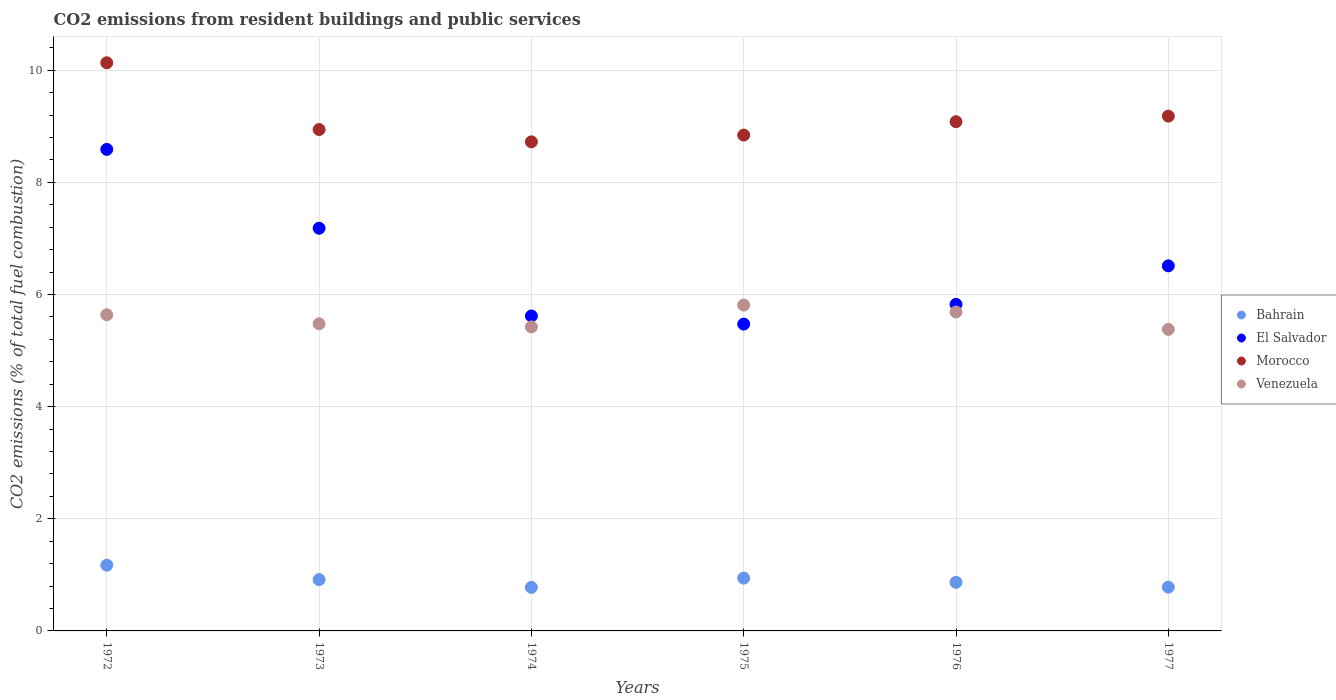Is the number of dotlines equal to the number of legend labels?
Your response must be concise. Yes. What is the total CO2 emitted in Bahrain in 1974?
Keep it short and to the point. 0.78. Across all years, what is the maximum total CO2 emitted in Bahrain?
Give a very brief answer. 1.17. Across all years, what is the minimum total CO2 emitted in Venezuela?
Your answer should be very brief. 5.38. In which year was the total CO2 emitted in El Salvador maximum?
Make the answer very short. 1972. In which year was the total CO2 emitted in Morocco minimum?
Provide a succinct answer. 1974. What is the total total CO2 emitted in Bahrain in the graph?
Offer a terse response. 5.45. What is the difference between the total CO2 emitted in Morocco in 1972 and that in 1976?
Ensure brevity in your answer.  1.05. What is the difference between the total CO2 emitted in Bahrain in 1972 and the total CO2 emitted in Venezuela in 1977?
Provide a succinct answer. -4.21. What is the average total CO2 emitted in El Salvador per year?
Offer a terse response. 6.53. In the year 1974, what is the difference between the total CO2 emitted in Morocco and total CO2 emitted in Bahrain?
Your answer should be very brief. 7.95. What is the ratio of the total CO2 emitted in El Salvador in 1975 to that in 1977?
Provide a succinct answer. 0.84. Is the total CO2 emitted in Bahrain in 1972 less than that in 1974?
Your response must be concise. No. Is the difference between the total CO2 emitted in Morocco in 1972 and 1974 greater than the difference between the total CO2 emitted in Bahrain in 1972 and 1974?
Provide a short and direct response. Yes. What is the difference between the highest and the second highest total CO2 emitted in Bahrain?
Your answer should be compact. 0.23. What is the difference between the highest and the lowest total CO2 emitted in Bahrain?
Provide a succinct answer. 0.4. Is it the case that in every year, the sum of the total CO2 emitted in Morocco and total CO2 emitted in Venezuela  is greater than the sum of total CO2 emitted in Bahrain and total CO2 emitted in El Salvador?
Provide a short and direct response. Yes. How many years are there in the graph?
Provide a short and direct response. 6. Are the values on the major ticks of Y-axis written in scientific E-notation?
Your answer should be very brief. No. Does the graph contain grids?
Give a very brief answer. Yes. How many legend labels are there?
Ensure brevity in your answer.  4. What is the title of the graph?
Offer a terse response. CO2 emissions from resident buildings and public services. Does "Bosnia and Herzegovina" appear as one of the legend labels in the graph?
Give a very brief answer. No. What is the label or title of the Y-axis?
Keep it short and to the point. CO2 emissions (% of total fuel combustion). What is the CO2 emissions (% of total fuel combustion) in Bahrain in 1972?
Offer a very short reply. 1.17. What is the CO2 emissions (% of total fuel combustion) of El Salvador in 1972?
Keep it short and to the point. 8.59. What is the CO2 emissions (% of total fuel combustion) in Morocco in 1972?
Your answer should be very brief. 10.13. What is the CO2 emissions (% of total fuel combustion) in Venezuela in 1972?
Provide a short and direct response. 5.64. What is the CO2 emissions (% of total fuel combustion) in Bahrain in 1973?
Ensure brevity in your answer.  0.92. What is the CO2 emissions (% of total fuel combustion) of El Salvador in 1973?
Your response must be concise. 7.18. What is the CO2 emissions (% of total fuel combustion) in Morocco in 1973?
Offer a very short reply. 8.94. What is the CO2 emissions (% of total fuel combustion) in Venezuela in 1973?
Your answer should be compact. 5.48. What is the CO2 emissions (% of total fuel combustion) of Bahrain in 1974?
Offer a very short reply. 0.78. What is the CO2 emissions (% of total fuel combustion) in El Salvador in 1974?
Give a very brief answer. 5.62. What is the CO2 emissions (% of total fuel combustion) in Morocco in 1974?
Ensure brevity in your answer.  8.72. What is the CO2 emissions (% of total fuel combustion) of Venezuela in 1974?
Your answer should be very brief. 5.42. What is the CO2 emissions (% of total fuel combustion) of Bahrain in 1975?
Your answer should be compact. 0.94. What is the CO2 emissions (% of total fuel combustion) in El Salvador in 1975?
Keep it short and to the point. 5.47. What is the CO2 emissions (% of total fuel combustion) of Morocco in 1975?
Provide a short and direct response. 8.84. What is the CO2 emissions (% of total fuel combustion) in Venezuela in 1975?
Provide a short and direct response. 5.81. What is the CO2 emissions (% of total fuel combustion) in Bahrain in 1976?
Ensure brevity in your answer.  0.87. What is the CO2 emissions (% of total fuel combustion) of El Salvador in 1976?
Give a very brief answer. 5.83. What is the CO2 emissions (% of total fuel combustion) in Morocco in 1976?
Make the answer very short. 9.08. What is the CO2 emissions (% of total fuel combustion) in Venezuela in 1976?
Ensure brevity in your answer.  5.69. What is the CO2 emissions (% of total fuel combustion) in Bahrain in 1977?
Provide a short and direct response. 0.78. What is the CO2 emissions (% of total fuel combustion) of El Salvador in 1977?
Provide a succinct answer. 6.51. What is the CO2 emissions (% of total fuel combustion) in Morocco in 1977?
Ensure brevity in your answer.  9.18. What is the CO2 emissions (% of total fuel combustion) in Venezuela in 1977?
Keep it short and to the point. 5.38. Across all years, what is the maximum CO2 emissions (% of total fuel combustion) in Bahrain?
Give a very brief answer. 1.17. Across all years, what is the maximum CO2 emissions (% of total fuel combustion) in El Salvador?
Your response must be concise. 8.59. Across all years, what is the maximum CO2 emissions (% of total fuel combustion) of Morocco?
Provide a succinct answer. 10.13. Across all years, what is the maximum CO2 emissions (% of total fuel combustion) in Venezuela?
Provide a short and direct response. 5.81. Across all years, what is the minimum CO2 emissions (% of total fuel combustion) of Bahrain?
Your answer should be compact. 0.78. Across all years, what is the minimum CO2 emissions (% of total fuel combustion) in El Salvador?
Ensure brevity in your answer.  5.47. Across all years, what is the minimum CO2 emissions (% of total fuel combustion) of Morocco?
Your response must be concise. 8.72. Across all years, what is the minimum CO2 emissions (% of total fuel combustion) of Venezuela?
Make the answer very short. 5.38. What is the total CO2 emissions (% of total fuel combustion) in Bahrain in the graph?
Ensure brevity in your answer.  5.45. What is the total CO2 emissions (% of total fuel combustion) in El Salvador in the graph?
Your answer should be very brief. 39.2. What is the total CO2 emissions (% of total fuel combustion) of Morocco in the graph?
Give a very brief answer. 54.91. What is the total CO2 emissions (% of total fuel combustion) of Venezuela in the graph?
Offer a very short reply. 33.42. What is the difference between the CO2 emissions (% of total fuel combustion) in Bahrain in 1972 and that in 1973?
Provide a succinct answer. 0.26. What is the difference between the CO2 emissions (% of total fuel combustion) of El Salvador in 1972 and that in 1973?
Make the answer very short. 1.41. What is the difference between the CO2 emissions (% of total fuel combustion) of Morocco in 1972 and that in 1973?
Your answer should be very brief. 1.19. What is the difference between the CO2 emissions (% of total fuel combustion) in Venezuela in 1972 and that in 1973?
Keep it short and to the point. 0.16. What is the difference between the CO2 emissions (% of total fuel combustion) of Bahrain in 1972 and that in 1974?
Keep it short and to the point. 0.4. What is the difference between the CO2 emissions (% of total fuel combustion) of El Salvador in 1972 and that in 1974?
Your response must be concise. 2.97. What is the difference between the CO2 emissions (% of total fuel combustion) of Morocco in 1972 and that in 1974?
Your response must be concise. 1.41. What is the difference between the CO2 emissions (% of total fuel combustion) of Venezuela in 1972 and that in 1974?
Make the answer very short. 0.22. What is the difference between the CO2 emissions (% of total fuel combustion) of Bahrain in 1972 and that in 1975?
Ensure brevity in your answer.  0.23. What is the difference between the CO2 emissions (% of total fuel combustion) of El Salvador in 1972 and that in 1975?
Provide a succinct answer. 3.12. What is the difference between the CO2 emissions (% of total fuel combustion) of Morocco in 1972 and that in 1975?
Your answer should be very brief. 1.29. What is the difference between the CO2 emissions (% of total fuel combustion) in Venezuela in 1972 and that in 1975?
Offer a terse response. -0.17. What is the difference between the CO2 emissions (% of total fuel combustion) in Bahrain in 1972 and that in 1976?
Your answer should be very brief. 0.31. What is the difference between the CO2 emissions (% of total fuel combustion) of El Salvador in 1972 and that in 1976?
Provide a short and direct response. 2.76. What is the difference between the CO2 emissions (% of total fuel combustion) of Morocco in 1972 and that in 1976?
Offer a very short reply. 1.05. What is the difference between the CO2 emissions (% of total fuel combustion) in Venezuela in 1972 and that in 1976?
Provide a short and direct response. -0.05. What is the difference between the CO2 emissions (% of total fuel combustion) in Bahrain in 1972 and that in 1977?
Offer a terse response. 0.39. What is the difference between the CO2 emissions (% of total fuel combustion) of El Salvador in 1972 and that in 1977?
Provide a short and direct response. 2.08. What is the difference between the CO2 emissions (% of total fuel combustion) of Morocco in 1972 and that in 1977?
Ensure brevity in your answer.  0.95. What is the difference between the CO2 emissions (% of total fuel combustion) of Venezuela in 1972 and that in 1977?
Your answer should be compact. 0.26. What is the difference between the CO2 emissions (% of total fuel combustion) in Bahrain in 1973 and that in 1974?
Keep it short and to the point. 0.14. What is the difference between the CO2 emissions (% of total fuel combustion) in El Salvador in 1973 and that in 1974?
Make the answer very short. 1.56. What is the difference between the CO2 emissions (% of total fuel combustion) of Morocco in 1973 and that in 1974?
Make the answer very short. 0.22. What is the difference between the CO2 emissions (% of total fuel combustion) in Venezuela in 1973 and that in 1974?
Provide a succinct answer. 0.06. What is the difference between the CO2 emissions (% of total fuel combustion) of Bahrain in 1973 and that in 1975?
Keep it short and to the point. -0.03. What is the difference between the CO2 emissions (% of total fuel combustion) of El Salvador in 1973 and that in 1975?
Provide a short and direct response. 1.71. What is the difference between the CO2 emissions (% of total fuel combustion) of Morocco in 1973 and that in 1975?
Provide a succinct answer. 0.1. What is the difference between the CO2 emissions (% of total fuel combustion) in Venezuela in 1973 and that in 1975?
Keep it short and to the point. -0.33. What is the difference between the CO2 emissions (% of total fuel combustion) in Bahrain in 1973 and that in 1976?
Give a very brief answer. 0.05. What is the difference between the CO2 emissions (% of total fuel combustion) of El Salvador in 1973 and that in 1976?
Make the answer very short. 1.36. What is the difference between the CO2 emissions (% of total fuel combustion) of Morocco in 1973 and that in 1976?
Make the answer very short. -0.14. What is the difference between the CO2 emissions (% of total fuel combustion) of Venezuela in 1973 and that in 1976?
Offer a very short reply. -0.21. What is the difference between the CO2 emissions (% of total fuel combustion) of Bahrain in 1973 and that in 1977?
Provide a succinct answer. 0.13. What is the difference between the CO2 emissions (% of total fuel combustion) in El Salvador in 1973 and that in 1977?
Offer a very short reply. 0.67. What is the difference between the CO2 emissions (% of total fuel combustion) of Morocco in 1973 and that in 1977?
Give a very brief answer. -0.24. What is the difference between the CO2 emissions (% of total fuel combustion) in Venezuela in 1973 and that in 1977?
Keep it short and to the point. 0.1. What is the difference between the CO2 emissions (% of total fuel combustion) in Bahrain in 1974 and that in 1975?
Offer a very short reply. -0.16. What is the difference between the CO2 emissions (% of total fuel combustion) of El Salvador in 1974 and that in 1975?
Offer a terse response. 0.15. What is the difference between the CO2 emissions (% of total fuel combustion) in Morocco in 1974 and that in 1975?
Your answer should be very brief. -0.12. What is the difference between the CO2 emissions (% of total fuel combustion) of Venezuela in 1974 and that in 1975?
Your response must be concise. -0.39. What is the difference between the CO2 emissions (% of total fuel combustion) in Bahrain in 1974 and that in 1976?
Ensure brevity in your answer.  -0.09. What is the difference between the CO2 emissions (% of total fuel combustion) in El Salvador in 1974 and that in 1976?
Offer a terse response. -0.21. What is the difference between the CO2 emissions (% of total fuel combustion) in Morocco in 1974 and that in 1976?
Give a very brief answer. -0.36. What is the difference between the CO2 emissions (% of total fuel combustion) of Venezuela in 1974 and that in 1976?
Offer a very short reply. -0.27. What is the difference between the CO2 emissions (% of total fuel combustion) in Bahrain in 1974 and that in 1977?
Provide a short and direct response. -0. What is the difference between the CO2 emissions (% of total fuel combustion) of El Salvador in 1974 and that in 1977?
Your answer should be very brief. -0.89. What is the difference between the CO2 emissions (% of total fuel combustion) in Morocco in 1974 and that in 1977?
Your answer should be compact. -0.46. What is the difference between the CO2 emissions (% of total fuel combustion) of Venezuela in 1974 and that in 1977?
Provide a succinct answer. 0.04. What is the difference between the CO2 emissions (% of total fuel combustion) of Bahrain in 1975 and that in 1976?
Your answer should be very brief. 0.08. What is the difference between the CO2 emissions (% of total fuel combustion) of El Salvador in 1975 and that in 1976?
Your answer should be compact. -0.35. What is the difference between the CO2 emissions (% of total fuel combustion) in Morocco in 1975 and that in 1976?
Your answer should be compact. -0.24. What is the difference between the CO2 emissions (% of total fuel combustion) in Venezuela in 1975 and that in 1976?
Ensure brevity in your answer.  0.12. What is the difference between the CO2 emissions (% of total fuel combustion) of Bahrain in 1975 and that in 1977?
Offer a very short reply. 0.16. What is the difference between the CO2 emissions (% of total fuel combustion) in El Salvador in 1975 and that in 1977?
Ensure brevity in your answer.  -1.04. What is the difference between the CO2 emissions (% of total fuel combustion) in Morocco in 1975 and that in 1977?
Give a very brief answer. -0.34. What is the difference between the CO2 emissions (% of total fuel combustion) of Venezuela in 1975 and that in 1977?
Provide a succinct answer. 0.43. What is the difference between the CO2 emissions (% of total fuel combustion) in Bahrain in 1976 and that in 1977?
Keep it short and to the point. 0.09. What is the difference between the CO2 emissions (% of total fuel combustion) in El Salvador in 1976 and that in 1977?
Offer a very short reply. -0.69. What is the difference between the CO2 emissions (% of total fuel combustion) in Morocco in 1976 and that in 1977?
Your answer should be very brief. -0.1. What is the difference between the CO2 emissions (% of total fuel combustion) in Venezuela in 1976 and that in 1977?
Your answer should be very brief. 0.31. What is the difference between the CO2 emissions (% of total fuel combustion) in Bahrain in 1972 and the CO2 emissions (% of total fuel combustion) in El Salvador in 1973?
Offer a terse response. -6.01. What is the difference between the CO2 emissions (% of total fuel combustion) of Bahrain in 1972 and the CO2 emissions (% of total fuel combustion) of Morocco in 1973?
Your answer should be very brief. -7.77. What is the difference between the CO2 emissions (% of total fuel combustion) of Bahrain in 1972 and the CO2 emissions (% of total fuel combustion) of Venezuela in 1973?
Your response must be concise. -4.31. What is the difference between the CO2 emissions (% of total fuel combustion) of El Salvador in 1972 and the CO2 emissions (% of total fuel combustion) of Morocco in 1973?
Offer a terse response. -0.35. What is the difference between the CO2 emissions (% of total fuel combustion) of El Salvador in 1972 and the CO2 emissions (% of total fuel combustion) of Venezuela in 1973?
Your response must be concise. 3.11. What is the difference between the CO2 emissions (% of total fuel combustion) of Morocco in 1972 and the CO2 emissions (% of total fuel combustion) of Venezuela in 1973?
Provide a succinct answer. 4.66. What is the difference between the CO2 emissions (% of total fuel combustion) in Bahrain in 1972 and the CO2 emissions (% of total fuel combustion) in El Salvador in 1974?
Your response must be concise. -4.45. What is the difference between the CO2 emissions (% of total fuel combustion) of Bahrain in 1972 and the CO2 emissions (% of total fuel combustion) of Morocco in 1974?
Offer a terse response. -7.55. What is the difference between the CO2 emissions (% of total fuel combustion) of Bahrain in 1972 and the CO2 emissions (% of total fuel combustion) of Venezuela in 1974?
Provide a short and direct response. -4.25. What is the difference between the CO2 emissions (% of total fuel combustion) of El Salvador in 1972 and the CO2 emissions (% of total fuel combustion) of Morocco in 1974?
Make the answer very short. -0.13. What is the difference between the CO2 emissions (% of total fuel combustion) of El Salvador in 1972 and the CO2 emissions (% of total fuel combustion) of Venezuela in 1974?
Your answer should be compact. 3.17. What is the difference between the CO2 emissions (% of total fuel combustion) of Morocco in 1972 and the CO2 emissions (% of total fuel combustion) of Venezuela in 1974?
Make the answer very short. 4.71. What is the difference between the CO2 emissions (% of total fuel combustion) in Bahrain in 1972 and the CO2 emissions (% of total fuel combustion) in El Salvador in 1975?
Offer a very short reply. -4.3. What is the difference between the CO2 emissions (% of total fuel combustion) in Bahrain in 1972 and the CO2 emissions (% of total fuel combustion) in Morocco in 1975?
Provide a short and direct response. -7.67. What is the difference between the CO2 emissions (% of total fuel combustion) in Bahrain in 1972 and the CO2 emissions (% of total fuel combustion) in Venezuela in 1975?
Make the answer very short. -4.64. What is the difference between the CO2 emissions (% of total fuel combustion) in El Salvador in 1972 and the CO2 emissions (% of total fuel combustion) in Morocco in 1975?
Provide a short and direct response. -0.26. What is the difference between the CO2 emissions (% of total fuel combustion) in El Salvador in 1972 and the CO2 emissions (% of total fuel combustion) in Venezuela in 1975?
Offer a terse response. 2.78. What is the difference between the CO2 emissions (% of total fuel combustion) in Morocco in 1972 and the CO2 emissions (% of total fuel combustion) in Venezuela in 1975?
Make the answer very short. 4.32. What is the difference between the CO2 emissions (% of total fuel combustion) of Bahrain in 1972 and the CO2 emissions (% of total fuel combustion) of El Salvador in 1976?
Your answer should be compact. -4.65. What is the difference between the CO2 emissions (% of total fuel combustion) of Bahrain in 1972 and the CO2 emissions (% of total fuel combustion) of Morocco in 1976?
Offer a very short reply. -7.91. What is the difference between the CO2 emissions (% of total fuel combustion) in Bahrain in 1972 and the CO2 emissions (% of total fuel combustion) in Venezuela in 1976?
Provide a short and direct response. -4.52. What is the difference between the CO2 emissions (% of total fuel combustion) of El Salvador in 1972 and the CO2 emissions (% of total fuel combustion) of Morocco in 1976?
Your response must be concise. -0.49. What is the difference between the CO2 emissions (% of total fuel combustion) in El Salvador in 1972 and the CO2 emissions (% of total fuel combustion) in Venezuela in 1976?
Your response must be concise. 2.9. What is the difference between the CO2 emissions (% of total fuel combustion) in Morocco in 1972 and the CO2 emissions (% of total fuel combustion) in Venezuela in 1976?
Ensure brevity in your answer.  4.44. What is the difference between the CO2 emissions (% of total fuel combustion) in Bahrain in 1972 and the CO2 emissions (% of total fuel combustion) in El Salvador in 1977?
Your answer should be compact. -5.34. What is the difference between the CO2 emissions (% of total fuel combustion) of Bahrain in 1972 and the CO2 emissions (% of total fuel combustion) of Morocco in 1977?
Your response must be concise. -8.01. What is the difference between the CO2 emissions (% of total fuel combustion) of Bahrain in 1972 and the CO2 emissions (% of total fuel combustion) of Venezuela in 1977?
Keep it short and to the point. -4.21. What is the difference between the CO2 emissions (% of total fuel combustion) of El Salvador in 1972 and the CO2 emissions (% of total fuel combustion) of Morocco in 1977?
Your answer should be very brief. -0.59. What is the difference between the CO2 emissions (% of total fuel combustion) of El Salvador in 1972 and the CO2 emissions (% of total fuel combustion) of Venezuela in 1977?
Offer a very short reply. 3.21. What is the difference between the CO2 emissions (% of total fuel combustion) in Morocco in 1972 and the CO2 emissions (% of total fuel combustion) in Venezuela in 1977?
Make the answer very short. 4.75. What is the difference between the CO2 emissions (% of total fuel combustion) of Bahrain in 1973 and the CO2 emissions (% of total fuel combustion) of El Salvador in 1974?
Ensure brevity in your answer.  -4.7. What is the difference between the CO2 emissions (% of total fuel combustion) in Bahrain in 1973 and the CO2 emissions (% of total fuel combustion) in Morocco in 1974?
Give a very brief answer. -7.81. What is the difference between the CO2 emissions (% of total fuel combustion) in Bahrain in 1973 and the CO2 emissions (% of total fuel combustion) in Venezuela in 1974?
Your answer should be compact. -4.51. What is the difference between the CO2 emissions (% of total fuel combustion) of El Salvador in 1973 and the CO2 emissions (% of total fuel combustion) of Morocco in 1974?
Give a very brief answer. -1.54. What is the difference between the CO2 emissions (% of total fuel combustion) in El Salvador in 1973 and the CO2 emissions (% of total fuel combustion) in Venezuela in 1974?
Offer a very short reply. 1.76. What is the difference between the CO2 emissions (% of total fuel combustion) in Morocco in 1973 and the CO2 emissions (% of total fuel combustion) in Venezuela in 1974?
Provide a succinct answer. 3.52. What is the difference between the CO2 emissions (% of total fuel combustion) in Bahrain in 1973 and the CO2 emissions (% of total fuel combustion) in El Salvador in 1975?
Give a very brief answer. -4.56. What is the difference between the CO2 emissions (% of total fuel combustion) of Bahrain in 1973 and the CO2 emissions (% of total fuel combustion) of Morocco in 1975?
Keep it short and to the point. -7.93. What is the difference between the CO2 emissions (% of total fuel combustion) in Bahrain in 1973 and the CO2 emissions (% of total fuel combustion) in Venezuela in 1975?
Offer a terse response. -4.9. What is the difference between the CO2 emissions (% of total fuel combustion) in El Salvador in 1973 and the CO2 emissions (% of total fuel combustion) in Morocco in 1975?
Your response must be concise. -1.66. What is the difference between the CO2 emissions (% of total fuel combustion) in El Salvador in 1973 and the CO2 emissions (% of total fuel combustion) in Venezuela in 1975?
Your answer should be very brief. 1.37. What is the difference between the CO2 emissions (% of total fuel combustion) in Morocco in 1973 and the CO2 emissions (% of total fuel combustion) in Venezuela in 1975?
Give a very brief answer. 3.13. What is the difference between the CO2 emissions (% of total fuel combustion) in Bahrain in 1973 and the CO2 emissions (% of total fuel combustion) in El Salvador in 1976?
Provide a short and direct response. -4.91. What is the difference between the CO2 emissions (% of total fuel combustion) of Bahrain in 1973 and the CO2 emissions (% of total fuel combustion) of Morocco in 1976?
Ensure brevity in your answer.  -8.17. What is the difference between the CO2 emissions (% of total fuel combustion) in Bahrain in 1973 and the CO2 emissions (% of total fuel combustion) in Venezuela in 1976?
Provide a short and direct response. -4.77. What is the difference between the CO2 emissions (% of total fuel combustion) in El Salvador in 1973 and the CO2 emissions (% of total fuel combustion) in Morocco in 1976?
Provide a short and direct response. -1.9. What is the difference between the CO2 emissions (% of total fuel combustion) in El Salvador in 1973 and the CO2 emissions (% of total fuel combustion) in Venezuela in 1976?
Make the answer very short. 1.49. What is the difference between the CO2 emissions (% of total fuel combustion) of Morocco in 1973 and the CO2 emissions (% of total fuel combustion) of Venezuela in 1976?
Provide a short and direct response. 3.25. What is the difference between the CO2 emissions (% of total fuel combustion) of Bahrain in 1973 and the CO2 emissions (% of total fuel combustion) of El Salvador in 1977?
Your answer should be very brief. -5.6. What is the difference between the CO2 emissions (% of total fuel combustion) of Bahrain in 1973 and the CO2 emissions (% of total fuel combustion) of Morocco in 1977?
Your response must be concise. -8.27. What is the difference between the CO2 emissions (% of total fuel combustion) in Bahrain in 1973 and the CO2 emissions (% of total fuel combustion) in Venezuela in 1977?
Your answer should be compact. -4.46. What is the difference between the CO2 emissions (% of total fuel combustion) in El Salvador in 1973 and the CO2 emissions (% of total fuel combustion) in Morocco in 1977?
Offer a terse response. -2. What is the difference between the CO2 emissions (% of total fuel combustion) of El Salvador in 1973 and the CO2 emissions (% of total fuel combustion) of Venezuela in 1977?
Offer a very short reply. 1.8. What is the difference between the CO2 emissions (% of total fuel combustion) of Morocco in 1973 and the CO2 emissions (% of total fuel combustion) of Venezuela in 1977?
Your answer should be very brief. 3.56. What is the difference between the CO2 emissions (% of total fuel combustion) of Bahrain in 1974 and the CO2 emissions (% of total fuel combustion) of El Salvador in 1975?
Your answer should be very brief. -4.7. What is the difference between the CO2 emissions (% of total fuel combustion) in Bahrain in 1974 and the CO2 emissions (% of total fuel combustion) in Morocco in 1975?
Provide a short and direct response. -8.07. What is the difference between the CO2 emissions (% of total fuel combustion) in Bahrain in 1974 and the CO2 emissions (% of total fuel combustion) in Venezuela in 1975?
Keep it short and to the point. -5.04. What is the difference between the CO2 emissions (% of total fuel combustion) in El Salvador in 1974 and the CO2 emissions (% of total fuel combustion) in Morocco in 1975?
Your answer should be compact. -3.23. What is the difference between the CO2 emissions (% of total fuel combustion) in El Salvador in 1974 and the CO2 emissions (% of total fuel combustion) in Venezuela in 1975?
Keep it short and to the point. -0.19. What is the difference between the CO2 emissions (% of total fuel combustion) in Morocco in 1974 and the CO2 emissions (% of total fuel combustion) in Venezuela in 1975?
Give a very brief answer. 2.91. What is the difference between the CO2 emissions (% of total fuel combustion) of Bahrain in 1974 and the CO2 emissions (% of total fuel combustion) of El Salvador in 1976?
Your answer should be very brief. -5.05. What is the difference between the CO2 emissions (% of total fuel combustion) in Bahrain in 1974 and the CO2 emissions (% of total fuel combustion) in Morocco in 1976?
Ensure brevity in your answer.  -8.31. What is the difference between the CO2 emissions (% of total fuel combustion) in Bahrain in 1974 and the CO2 emissions (% of total fuel combustion) in Venezuela in 1976?
Your response must be concise. -4.91. What is the difference between the CO2 emissions (% of total fuel combustion) of El Salvador in 1974 and the CO2 emissions (% of total fuel combustion) of Morocco in 1976?
Make the answer very short. -3.46. What is the difference between the CO2 emissions (% of total fuel combustion) of El Salvador in 1974 and the CO2 emissions (% of total fuel combustion) of Venezuela in 1976?
Your answer should be very brief. -0.07. What is the difference between the CO2 emissions (% of total fuel combustion) of Morocco in 1974 and the CO2 emissions (% of total fuel combustion) of Venezuela in 1976?
Your answer should be very brief. 3.03. What is the difference between the CO2 emissions (% of total fuel combustion) of Bahrain in 1974 and the CO2 emissions (% of total fuel combustion) of El Salvador in 1977?
Provide a succinct answer. -5.73. What is the difference between the CO2 emissions (% of total fuel combustion) in Bahrain in 1974 and the CO2 emissions (% of total fuel combustion) in Morocco in 1977?
Keep it short and to the point. -8.41. What is the difference between the CO2 emissions (% of total fuel combustion) in Bahrain in 1974 and the CO2 emissions (% of total fuel combustion) in Venezuela in 1977?
Your answer should be compact. -4.6. What is the difference between the CO2 emissions (% of total fuel combustion) of El Salvador in 1974 and the CO2 emissions (% of total fuel combustion) of Morocco in 1977?
Provide a succinct answer. -3.56. What is the difference between the CO2 emissions (% of total fuel combustion) of El Salvador in 1974 and the CO2 emissions (% of total fuel combustion) of Venezuela in 1977?
Your answer should be very brief. 0.24. What is the difference between the CO2 emissions (% of total fuel combustion) in Morocco in 1974 and the CO2 emissions (% of total fuel combustion) in Venezuela in 1977?
Give a very brief answer. 3.35. What is the difference between the CO2 emissions (% of total fuel combustion) of Bahrain in 1975 and the CO2 emissions (% of total fuel combustion) of El Salvador in 1976?
Your response must be concise. -4.88. What is the difference between the CO2 emissions (% of total fuel combustion) of Bahrain in 1975 and the CO2 emissions (% of total fuel combustion) of Morocco in 1976?
Keep it short and to the point. -8.14. What is the difference between the CO2 emissions (% of total fuel combustion) of Bahrain in 1975 and the CO2 emissions (% of total fuel combustion) of Venezuela in 1976?
Provide a short and direct response. -4.75. What is the difference between the CO2 emissions (% of total fuel combustion) of El Salvador in 1975 and the CO2 emissions (% of total fuel combustion) of Morocco in 1976?
Keep it short and to the point. -3.61. What is the difference between the CO2 emissions (% of total fuel combustion) of El Salvador in 1975 and the CO2 emissions (% of total fuel combustion) of Venezuela in 1976?
Your answer should be compact. -0.22. What is the difference between the CO2 emissions (% of total fuel combustion) in Morocco in 1975 and the CO2 emissions (% of total fuel combustion) in Venezuela in 1976?
Your answer should be compact. 3.16. What is the difference between the CO2 emissions (% of total fuel combustion) in Bahrain in 1975 and the CO2 emissions (% of total fuel combustion) in El Salvador in 1977?
Keep it short and to the point. -5.57. What is the difference between the CO2 emissions (% of total fuel combustion) in Bahrain in 1975 and the CO2 emissions (% of total fuel combustion) in Morocco in 1977?
Your answer should be compact. -8.24. What is the difference between the CO2 emissions (% of total fuel combustion) in Bahrain in 1975 and the CO2 emissions (% of total fuel combustion) in Venezuela in 1977?
Your response must be concise. -4.44. What is the difference between the CO2 emissions (% of total fuel combustion) of El Salvador in 1975 and the CO2 emissions (% of total fuel combustion) of Morocco in 1977?
Offer a very short reply. -3.71. What is the difference between the CO2 emissions (% of total fuel combustion) of El Salvador in 1975 and the CO2 emissions (% of total fuel combustion) of Venezuela in 1977?
Give a very brief answer. 0.09. What is the difference between the CO2 emissions (% of total fuel combustion) of Morocco in 1975 and the CO2 emissions (% of total fuel combustion) of Venezuela in 1977?
Give a very brief answer. 3.47. What is the difference between the CO2 emissions (% of total fuel combustion) of Bahrain in 1976 and the CO2 emissions (% of total fuel combustion) of El Salvador in 1977?
Keep it short and to the point. -5.65. What is the difference between the CO2 emissions (% of total fuel combustion) in Bahrain in 1976 and the CO2 emissions (% of total fuel combustion) in Morocco in 1977?
Keep it short and to the point. -8.32. What is the difference between the CO2 emissions (% of total fuel combustion) in Bahrain in 1976 and the CO2 emissions (% of total fuel combustion) in Venezuela in 1977?
Make the answer very short. -4.51. What is the difference between the CO2 emissions (% of total fuel combustion) in El Salvador in 1976 and the CO2 emissions (% of total fuel combustion) in Morocco in 1977?
Keep it short and to the point. -3.36. What is the difference between the CO2 emissions (% of total fuel combustion) in El Salvador in 1976 and the CO2 emissions (% of total fuel combustion) in Venezuela in 1977?
Keep it short and to the point. 0.45. What is the difference between the CO2 emissions (% of total fuel combustion) in Morocco in 1976 and the CO2 emissions (% of total fuel combustion) in Venezuela in 1977?
Provide a succinct answer. 3.7. What is the average CO2 emissions (% of total fuel combustion) in El Salvador per year?
Your answer should be compact. 6.53. What is the average CO2 emissions (% of total fuel combustion) of Morocco per year?
Make the answer very short. 9.15. What is the average CO2 emissions (% of total fuel combustion) in Venezuela per year?
Ensure brevity in your answer.  5.57. In the year 1972, what is the difference between the CO2 emissions (% of total fuel combustion) of Bahrain and CO2 emissions (% of total fuel combustion) of El Salvador?
Offer a very short reply. -7.42. In the year 1972, what is the difference between the CO2 emissions (% of total fuel combustion) of Bahrain and CO2 emissions (% of total fuel combustion) of Morocco?
Keep it short and to the point. -8.96. In the year 1972, what is the difference between the CO2 emissions (% of total fuel combustion) of Bahrain and CO2 emissions (% of total fuel combustion) of Venezuela?
Your answer should be compact. -4.47. In the year 1972, what is the difference between the CO2 emissions (% of total fuel combustion) in El Salvador and CO2 emissions (% of total fuel combustion) in Morocco?
Your response must be concise. -1.54. In the year 1972, what is the difference between the CO2 emissions (% of total fuel combustion) in El Salvador and CO2 emissions (% of total fuel combustion) in Venezuela?
Ensure brevity in your answer.  2.95. In the year 1972, what is the difference between the CO2 emissions (% of total fuel combustion) of Morocco and CO2 emissions (% of total fuel combustion) of Venezuela?
Ensure brevity in your answer.  4.49. In the year 1973, what is the difference between the CO2 emissions (% of total fuel combustion) of Bahrain and CO2 emissions (% of total fuel combustion) of El Salvador?
Your answer should be compact. -6.27. In the year 1973, what is the difference between the CO2 emissions (% of total fuel combustion) of Bahrain and CO2 emissions (% of total fuel combustion) of Morocco?
Give a very brief answer. -8.03. In the year 1973, what is the difference between the CO2 emissions (% of total fuel combustion) in Bahrain and CO2 emissions (% of total fuel combustion) in Venezuela?
Give a very brief answer. -4.56. In the year 1973, what is the difference between the CO2 emissions (% of total fuel combustion) of El Salvador and CO2 emissions (% of total fuel combustion) of Morocco?
Your response must be concise. -1.76. In the year 1973, what is the difference between the CO2 emissions (% of total fuel combustion) of El Salvador and CO2 emissions (% of total fuel combustion) of Venezuela?
Your answer should be very brief. 1.7. In the year 1973, what is the difference between the CO2 emissions (% of total fuel combustion) in Morocco and CO2 emissions (% of total fuel combustion) in Venezuela?
Keep it short and to the point. 3.46. In the year 1974, what is the difference between the CO2 emissions (% of total fuel combustion) in Bahrain and CO2 emissions (% of total fuel combustion) in El Salvador?
Provide a succinct answer. -4.84. In the year 1974, what is the difference between the CO2 emissions (% of total fuel combustion) in Bahrain and CO2 emissions (% of total fuel combustion) in Morocco?
Ensure brevity in your answer.  -7.95. In the year 1974, what is the difference between the CO2 emissions (% of total fuel combustion) of Bahrain and CO2 emissions (% of total fuel combustion) of Venezuela?
Your response must be concise. -4.65. In the year 1974, what is the difference between the CO2 emissions (% of total fuel combustion) in El Salvador and CO2 emissions (% of total fuel combustion) in Morocco?
Give a very brief answer. -3.11. In the year 1974, what is the difference between the CO2 emissions (% of total fuel combustion) of El Salvador and CO2 emissions (% of total fuel combustion) of Venezuela?
Give a very brief answer. 0.2. In the year 1974, what is the difference between the CO2 emissions (% of total fuel combustion) of Morocco and CO2 emissions (% of total fuel combustion) of Venezuela?
Offer a terse response. 3.3. In the year 1975, what is the difference between the CO2 emissions (% of total fuel combustion) in Bahrain and CO2 emissions (% of total fuel combustion) in El Salvador?
Keep it short and to the point. -4.53. In the year 1975, what is the difference between the CO2 emissions (% of total fuel combustion) in Bahrain and CO2 emissions (% of total fuel combustion) in Morocco?
Your response must be concise. -7.9. In the year 1975, what is the difference between the CO2 emissions (% of total fuel combustion) of Bahrain and CO2 emissions (% of total fuel combustion) of Venezuela?
Offer a very short reply. -4.87. In the year 1975, what is the difference between the CO2 emissions (% of total fuel combustion) in El Salvador and CO2 emissions (% of total fuel combustion) in Morocco?
Provide a succinct answer. -3.37. In the year 1975, what is the difference between the CO2 emissions (% of total fuel combustion) in El Salvador and CO2 emissions (% of total fuel combustion) in Venezuela?
Offer a very short reply. -0.34. In the year 1975, what is the difference between the CO2 emissions (% of total fuel combustion) in Morocco and CO2 emissions (% of total fuel combustion) in Venezuela?
Your answer should be very brief. 3.03. In the year 1976, what is the difference between the CO2 emissions (% of total fuel combustion) of Bahrain and CO2 emissions (% of total fuel combustion) of El Salvador?
Provide a succinct answer. -4.96. In the year 1976, what is the difference between the CO2 emissions (% of total fuel combustion) in Bahrain and CO2 emissions (% of total fuel combustion) in Morocco?
Your answer should be compact. -8.22. In the year 1976, what is the difference between the CO2 emissions (% of total fuel combustion) in Bahrain and CO2 emissions (% of total fuel combustion) in Venezuela?
Provide a short and direct response. -4.82. In the year 1976, what is the difference between the CO2 emissions (% of total fuel combustion) of El Salvador and CO2 emissions (% of total fuel combustion) of Morocco?
Keep it short and to the point. -3.26. In the year 1976, what is the difference between the CO2 emissions (% of total fuel combustion) of El Salvador and CO2 emissions (% of total fuel combustion) of Venezuela?
Give a very brief answer. 0.14. In the year 1976, what is the difference between the CO2 emissions (% of total fuel combustion) of Morocco and CO2 emissions (% of total fuel combustion) of Venezuela?
Provide a succinct answer. 3.39. In the year 1977, what is the difference between the CO2 emissions (% of total fuel combustion) in Bahrain and CO2 emissions (% of total fuel combustion) in El Salvador?
Provide a succinct answer. -5.73. In the year 1977, what is the difference between the CO2 emissions (% of total fuel combustion) in Bahrain and CO2 emissions (% of total fuel combustion) in Morocco?
Provide a succinct answer. -8.4. In the year 1977, what is the difference between the CO2 emissions (% of total fuel combustion) in Bahrain and CO2 emissions (% of total fuel combustion) in Venezuela?
Provide a short and direct response. -4.6. In the year 1977, what is the difference between the CO2 emissions (% of total fuel combustion) in El Salvador and CO2 emissions (% of total fuel combustion) in Morocco?
Give a very brief answer. -2.67. In the year 1977, what is the difference between the CO2 emissions (% of total fuel combustion) in El Salvador and CO2 emissions (% of total fuel combustion) in Venezuela?
Your answer should be very brief. 1.13. In the year 1977, what is the difference between the CO2 emissions (% of total fuel combustion) in Morocco and CO2 emissions (% of total fuel combustion) in Venezuela?
Provide a short and direct response. 3.8. What is the ratio of the CO2 emissions (% of total fuel combustion) in Bahrain in 1972 to that in 1973?
Keep it short and to the point. 1.28. What is the ratio of the CO2 emissions (% of total fuel combustion) in El Salvador in 1972 to that in 1973?
Offer a terse response. 1.2. What is the ratio of the CO2 emissions (% of total fuel combustion) in Morocco in 1972 to that in 1973?
Offer a very short reply. 1.13. What is the ratio of the CO2 emissions (% of total fuel combustion) of Venezuela in 1972 to that in 1973?
Offer a very short reply. 1.03. What is the ratio of the CO2 emissions (% of total fuel combustion) in Bahrain in 1972 to that in 1974?
Offer a terse response. 1.51. What is the ratio of the CO2 emissions (% of total fuel combustion) of El Salvador in 1972 to that in 1974?
Keep it short and to the point. 1.53. What is the ratio of the CO2 emissions (% of total fuel combustion) in Morocco in 1972 to that in 1974?
Offer a very short reply. 1.16. What is the ratio of the CO2 emissions (% of total fuel combustion) of Venezuela in 1972 to that in 1974?
Provide a succinct answer. 1.04. What is the ratio of the CO2 emissions (% of total fuel combustion) in Bahrain in 1972 to that in 1975?
Ensure brevity in your answer.  1.25. What is the ratio of the CO2 emissions (% of total fuel combustion) in El Salvador in 1972 to that in 1975?
Give a very brief answer. 1.57. What is the ratio of the CO2 emissions (% of total fuel combustion) in Morocco in 1972 to that in 1975?
Provide a short and direct response. 1.15. What is the ratio of the CO2 emissions (% of total fuel combustion) of Venezuela in 1972 to that in 1975?
Provide a succinct answer. 0.97. What is the ratio of the CO2 emissions (% of total fuel combustion) in Bahrain in 1972 to that in 1976?
Ensure brevity in your answer.  1.35. What is the ratio of the CO2 emissions (% of total fuel combustion) of El Salvador in 1972 to that in 1976?
Make the answer very short. 1.47. What is the ratio of the CO2 emissions (% of total fuel combustion) in Morocco in 1972 to that in 1976?
Provide a succinct answer. 1.12. What is the ratio of the CO2 emissions (% of total fuel combustion) in Venezuela in 1972 to that in 1976?
Ensure brevity in your answer.  0.99. What is the ratio of the CO2 emissions (% of total fuel combustion) of Bahrain in 1972 to that in 1977?
Your answer should be very brief. 1.5. What is the ratio of the CO2 emissions (% of total fuel combustion) in El Salvador in 1972 to that in 1977?
Make the answer very short. 1.32. What is the ratio of the CO2 emissions (% of total fuel combustion) of Morocco in 1972 to that in 1977?
Keep it short and to the point. 1.1. What is the ratio of the CO2 emissions (% of total fuel combustion) in Venezuela in 1972 to that in 1977?
Offer a terse response. 1.05. What is the ratio of the CO2 emissions (% of total fuel combustion) in Bahrain in 1973 to that in 1974?
Your answer should be compact. 1.18. What is the ratio of the CO2 emissions (% of total fuel combustion) in El Salvador in 1973 to that in 1974?
Ensure brevity in your answer.  1.28. What is the ratio of the CO2 emissions (% of total fuel combustion) in Morocco in 1973 to that in 1974?
Your answer should be compact. 1.03. What is the ratio of the CO2 emissions (% of total fuel combustion) of Venezuela in 1973 to that in 1974?
Keep it short and to the point. 1.01. What is the ratio of the CO2 emissions (% of total fuel combustion) in Bahrain in 1973 to that in 1975?
Offer a very short reply. 0.97. What is the ratio of the CO2 emissions (% of total fuel combustion) of El Salvador in 1973 to that in 1975?
Provide a succinct answer. 1.31. What is the ratio of the CO2 emissions (% of total fuel combustion) in Morocco in 1973 to that in 1975?
Offer a terse response. 1.01. What is the ratio of the CO2 emissions (% of total fuel combustion) in Venezuela in 1973 to that in 1975?
Keep it short and to the point. 0.94. What is the ratio of the CO2 emissions (% of total fuel combustion) in Bahrain in 1973 to that in 1976?
Provide a succinct answer. 1.06. What is the ratio of the CO2 emissions (% of total fuel combustion) in El Salvador in 1973 to that in 1976?
Give a very brief answer. 1.23. What is the ratio of the CO2 emissions (% of total fuel combustion) in Morocco in 1973 to that in 1976?
Your answer should be very brief. 0.98. What is the ratio of the CO2 emissions (% of total fuel combustion) of Bahrain in 1973 to that in 1977?
Give a very brief answer. 1.17. What is the ratio of the CO2 emissions (% of total fuel combustion) of El Salvador in 1973 to that in 1977?
Give a very brief answer. 1.1. What is the ratio of the CO2 emissions (% of total fuel combustion) in Morocco in 1973 to that in 1977?
Your answer should be compact. 0.97. What is the ratio of the CO2 emissions (% of total fuel combustion) of Venezuela in 1973 to that in 1977?
Provide a succinct answer. 1.02. What is the ratio of the CO2 emissions (% of total fuel combustion) of Bahrain in 1974 to that in 1975?
Give a very brief answer. 0.82. What is the ratio of the CO2 emissions (% of total fuel combustion) of El Salvador in 1974 to that in 1975?
Provide a succinct answer. 1.03. What is the ratio of the CO2 emissions (% of total fuel combustion) in Morocco in 1974 to that in 1975?
Offer a terse response. 0.99. What is the ratio of the CO2 emissions (% of total fuel combustion) of Venezuela in 1974 to that in 1975?
Ensure brevity in your answer.  0.93. What is the ratio of the CO2 emissions (% of total fuel combustion) in Bahrain in 1974 to that in 1976?
Your answer should be compact. 0.9. What is the ratio of the CO2 emissions (% of total fuel combustion) of El Salvador in 1974 to that in 1976?
Provide a short and direct response. 0.96. What is the ratio of the CO2 emissions (% of total fuel combustion) of Morocco in 1974 to that in 1976?
Keep it short and to the point. 0.96. What is the ratio of the CO2 emissions (% of total fuel combustion) of Venezuela in 1974 to that in 1976?
Give a very brief answer. 0.95. What is the ratio of the CO2 emissions (% of total fuel combustion) in Bahrain in 1974 to that in 1977?
Your response must be concise. 0.99. What is the ratio of the CO2 emissions (% of total fuel combustion) of El Salvador in 1974 to that in 1977?
Make the answer very short. 0.86. What is the ratio of the CO2 emissions (% of total fuel combustion) of Morocco in 1974 to that in 1977?
Keep it short and to the point. 0.95. What is the ratio of the CO2 emissions (% of total fuel combustion) of Venezuela in 1974 to that in 1977?
Give a very brief answer. 1.01. What is the ratio of the CO2 emissions (% of total fuel combustion) in Bahrain in 1975 to that in 1976?
Offer a very short reply. 1.09. What is the ratio of the CO2 emissions (% of total fuel combustion) of El Salvador in 1975 to that in 1976?
Keep it short and to the point. 0.94. What is the ratio of the CO2 emissions (% of total fuel combustion) in Morocco in 1975 to that in 1976?
Make the answer very short. 0.97. What is the ratio of the CO2 emissions (% of total fuel combustion) in Venezuela in 1975 to that in 1976?
Offer a terse response. 1.02. What is the ratio of the CO2 emissions (% of total fuel combustion) in Bahrain in 1975 to that in 1977?
Your answer should be compact. 1.21. What is the ratio of the CO2 emissions (% of total fuel combustion) of El Salvador in 1975 to that in 1977?
Your response must be concise. 0.84. What is the ratio of the CO2 emissions (% of total fuel combustion) in Morocco in 1975 to that in 1977?
Give a very brief answer. 0.96. What is the ratio of the CO2 emissions (% of total fuel combustion) in Venezuela in 1975 to that in 1977?
Give a very brief answer. 1.08. What is the ratio of the CO2 emissions (% of total fuel combustion) of Bahrain in 1976 to that in 1977?
Your response must be concise. 1.11. What is the ratio of the CO2 emissions (% of total fuel combustion) in El Salvador in 1976 to that in 1977?
Offer a very short reply. 0.89. What is the ratio of the CO2 emissions (% of total fuel combustion) of Morocco in 1976 to that in 1977?
Your answer should be very brief. 0.99. What is the ratio of the CO2 emissions (% of total fuel combustion) of Venezuela in 1976 to that in 1977?
Your answer should be compact. 1.06. What is the difference between the highest and the second highest CO2 emissions (% of total fuel combustion) of Bahrain?
Keep it short and to the point. 0.23. What is the difference between the highest and the second highest CO2 emissions (% of total fuel combustion) of El Salvador?
Make the answer very short. 1.41. What is the difference between the highest and the second highest CO2 emissions (% of total fuel combustion) in Morocco?
Your response must be concise. 0.95. What is the difference between the highest and the second highest CO2 emissions (% of total fuel combustion) in Venezuela?
Offer a very short reply. 0.12. What is the difference between the highest and the lowest CO2 emissions (% of total fuel combustion) of Bahrain?
Keep it short and to the point. 0.4. What is the difference between the highest and the lowest CO2 emissions (% of total fuel combustion) of El Salvador?
Make the answer very short. 3.12. What is the difference between the highest and the lowest CO2 emissions (% of total fuel combustion) in Morocco?
Your response must be concise. 1.41. What is the difference between the highest and the lowest CO2 emissions (% of total fuel combustion) in Venezuela?
Provide a short and direct response. 0.43. 